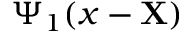<formula> <loc_0><loc_0><loc_500><loc_500>\Psi _ { 1 } ( x - X )</formula> 